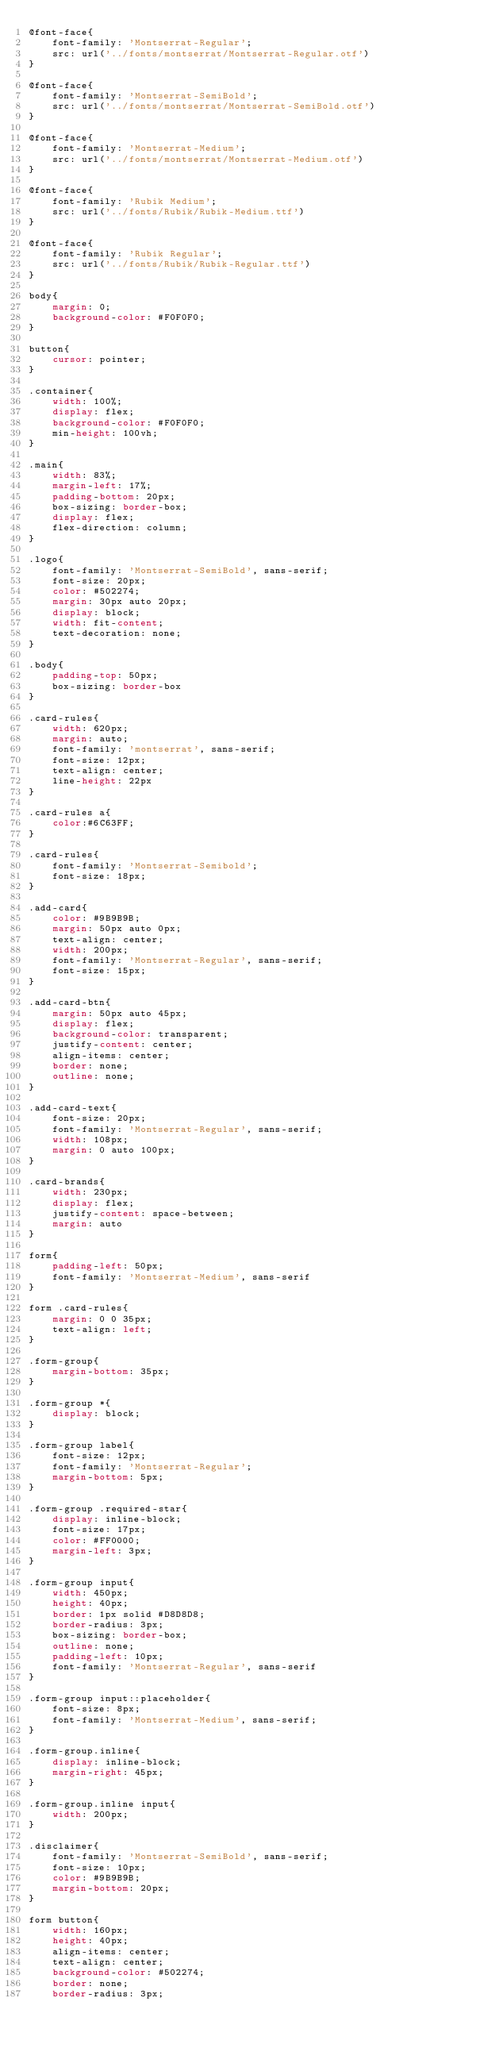<code> <loc_0><loc_0><loc_500><loc_500><_CSS_>@font-face{
    font-family: 'Montserrat-Regular';
    src: url('../fonts/montserrat/Montserrat-Regular.otf')
}

@font-face{
    font-family: 'Montserrat-SemiBold';
    src: url('../fonts/montserrat/Montserrat-SemiBold.otf')
}

@font-face{
    font-family: 'Montserrat-Medium';
    src: url('../fonts/montserrat/Montserrat-Medium.otf')
}

@font-face{
    font-family: 'Rubik Medium';
    src: url('../fonts/Rubik/Rubik-Medium.ttf')
}

@font-face{
    font-family: 'Rubik Regular';
    src: url('../fonts/Rubik/Rubik-Regular.ttf')
}

body{
    margin: 0;
    background-color: #F0F0F0;
}

button{
    cursor: pointer;
}

.container{
    width: 100%;
    display: flex;
    background-color: #F0F0F0;
    min-height: 100vh;
}

.main{
    width: 83%;
    margin-left: 17%;
    padding-bottom: 20px;
    box-sizing: border-box;
    display: flex;
    flex-direction: column;
}

.logo{
    font-family: 'Montserrat-SemiBold', sans-serif;
    font-size: 20px;
    color: #502274;
    margin: 30px auto 20px;
    display: block;
    width: fit-content;
    text-decoration: none;
}

.body{
    padding-top: 50px;
    box-sizing: border-box
}

.card-rules{
    width: 620px;
    margin: auto;
    font-family: 'montserrat', sans-serif;
    font-size: 12px;
    text-align: center;
    line-height: 22px
}

.card-rules a{
    color:#6C63FF;
}

.card-rules{
    font-family: 'Montserrat-Semibold';
    font-size: 18px;
}

.add-card{
    color: #9B9B9B;
    margin: 50px auto 0px;
    text-align: center;
    width: 200px;
    font-family: 'Montserrat-Regular', sans-serif;
    font-size: 15px;
}

.add-card-btn{
    margin: 50px auto 45px;
    display: flex;
    background-color: transparent;
    justify-content: center;
    align-items: center;
    border: none;
    outline: none;
}

.add-card-text{
    font-size: 20px;
    font-family: 'Montserrat-Regular', sans-serif;
    width: 108px;
    margin: 0 auto 100px;
}

.card-brands{
    width: 230px;
    display: flex;
    justify-content: space-between;
    margin: auto
}

form{
    padding-left: 50px;
    font-family: 'Montserrat-Medium', sans-serif
}

form .card-rules{
    margin: 0 0 35px;
    text-align: left;
}

.form-group{
    margin-bottom: 35px;
}

.form-group *{
    display: block;
}

.form-group label{
    font-size: 12px;
    font-family: 'Montserrat-Regular';
    margin-bottom: 5px;
}

.form-group .required-star{
    display: inline-block;
    font-size: 17px;
    color: #FF0000;
    margin-left: 3px;
}

.form-group input{
    width: 450px;
    height: 40px;
    border: 1px solid #D8D8D8;
    border-radius: 3px;
    box-sizing: border-box;
    outline: none;
    padding-left: 10px;
    font-family: 'Montserrat-Regular', sans-serif
}

.form-group input::placeholder{
    font-size: 8px;
    font-family: 'Montserrat-Medium', sans-serif;
}

.form-group.inline{
    display: inline-block;
    margin-right: 45px;
}

.form-group.inline input{
    width: 200px;
}

.disclaimer{
    font-family: 'Montserrat-SemiBold', sans-serif;
    font-size: 10px;
    color: #9B9B9B;
    margin-bottom: 20px;
}

form button{ 
    width: 160px;
    height: 40px;
    align-items: center;
    text-align: center;
    background-color: #502274;
    border: none;
    border-radius: 3px;</code> 